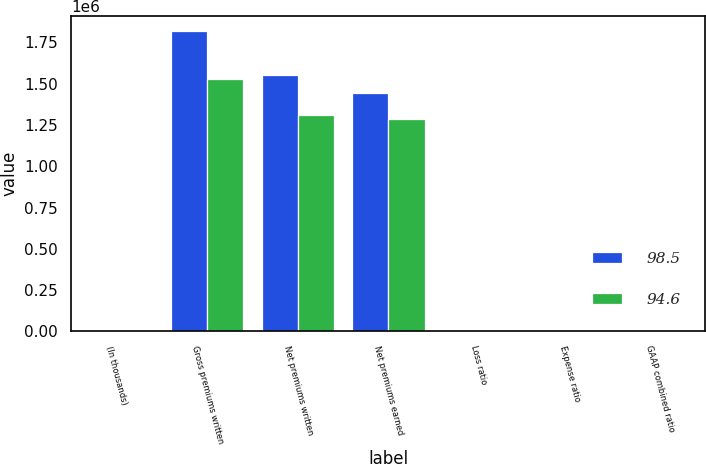<chart> <loc_0><loc_0><loc_500><loc_500><stacked_bar_chart><ecel><fcel>(In thousands)<fcel>Gross premiums written<fcel>Net premiums written<fcel>Net premiums earned<fcel>Loss ratio<fcel>Expense ratio<fcel>GAAP combined ratio<nl><fcel>98.5<fcel>2011<fcel>1.81834e+06<fcel>1.55452e+06<fcel>1.44275e+06<fcel>59.4<fcel>32.6<fcel>92<nl><fcel>94.6<fcel>2010<fcel>1.52586e+06<fcel>1.31183e+06<fcel>1.28837e+06<fcel>58.3<fcel>32.9<fcel>91.2<nl></chart> 